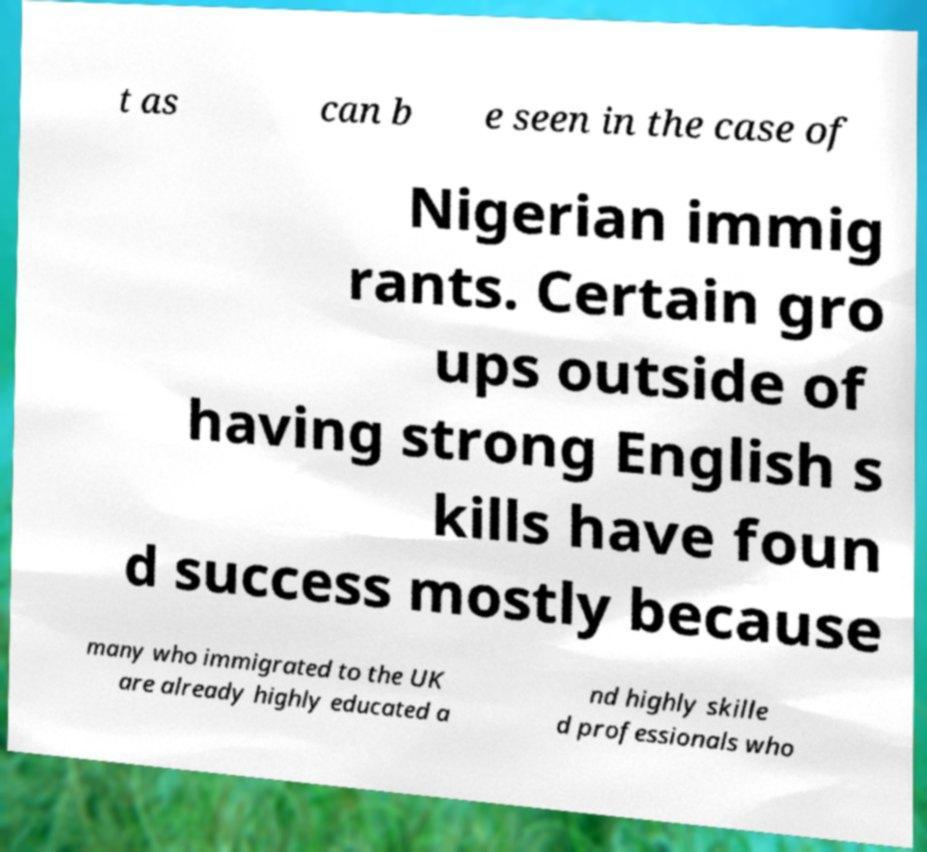What messages or text are displayed in this image? I need them in a readable, typed format. t as can b e seen in the case of Nigerian immig rants. Certain gro ups outside of having strong English s kills have foun d success mostly because many who immigrated to the UK are already highly educated a nd highly skille d professionals who 